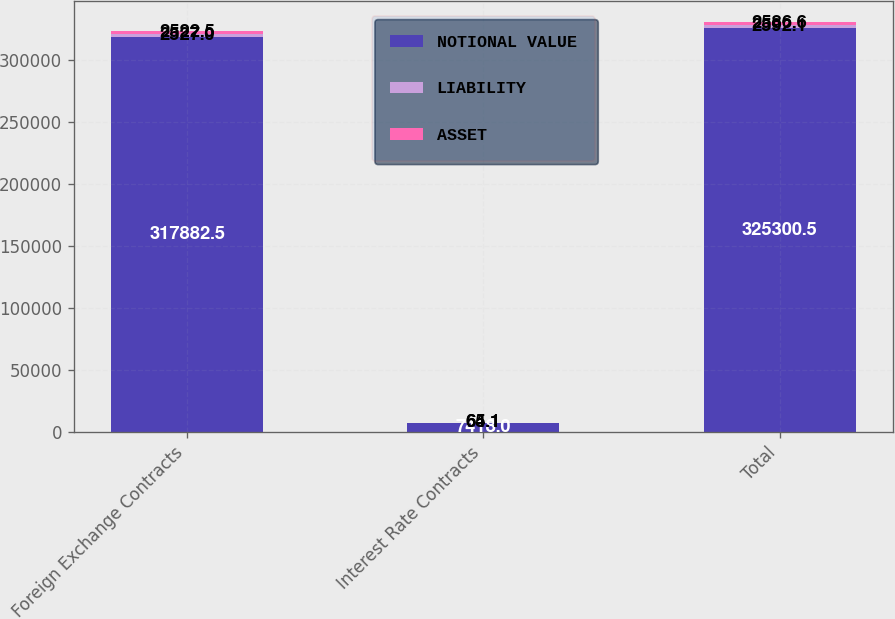<chart> <loc_0><loc_0><loc_500><loc_500><stacked_bar_chart><ecel><fcel>Foreign Exchange Contracts<fcel>Interest Rate Contracts<fcel>Total<nl><fcel>NOTIONAL VALUE<fcel>317882<fcel>7418<fcel>325300<nl><fcel>LIABILITY<fcel>2527<fcel>65.1<fcel>2592.1<nl><fcel>ASSET<fcel>2522.5<fcel>64.1<fcel>2586.6<nl></chart> 